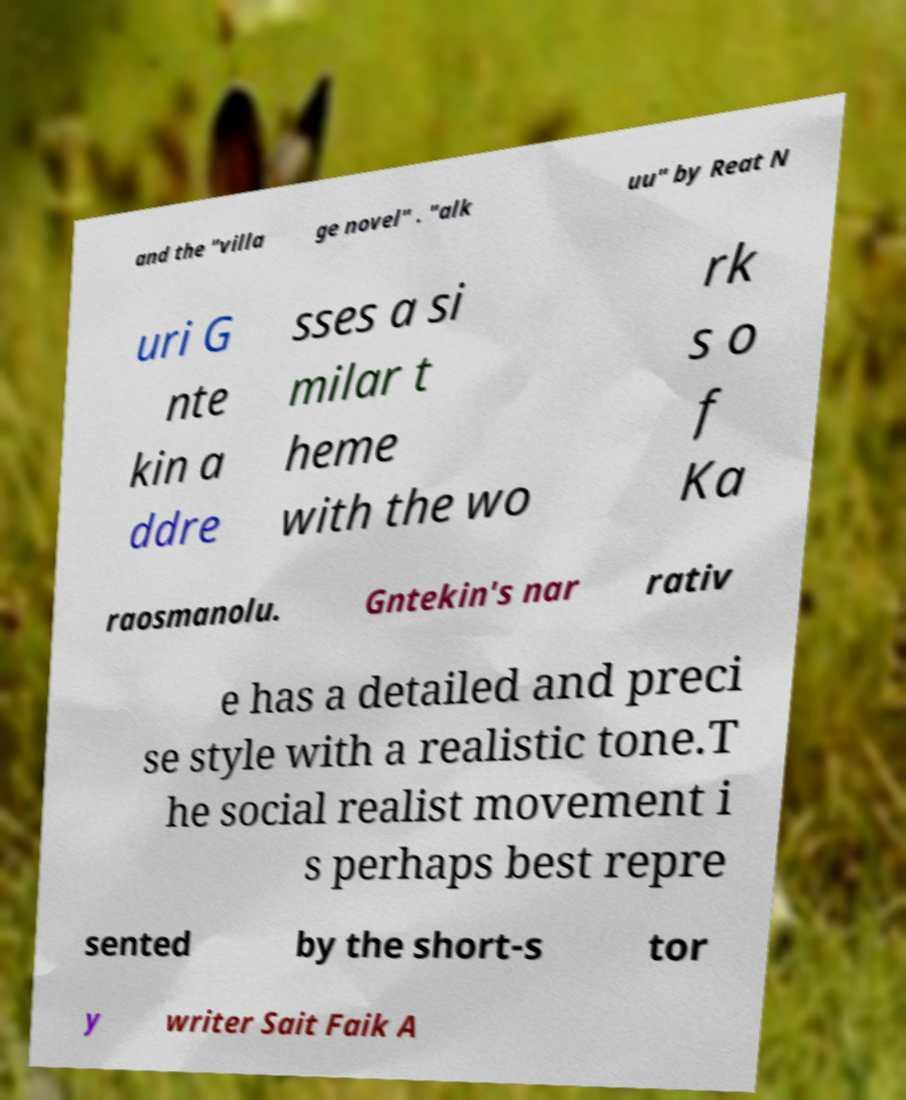Could you assist in decoding the text presented in this image and type it out clearly? and the "villa ge novel" . "alk uu" by Reat N uri G nte kin a ddre sses a si milar t heme with the wo rk s o f Ka raosmanolu. Gntekin's nar rativ e has a detailed and preci se style with a realistic tone.T he social realist movement i s perhaps best repre sented by the short-s tor y writer Sait Faik A 